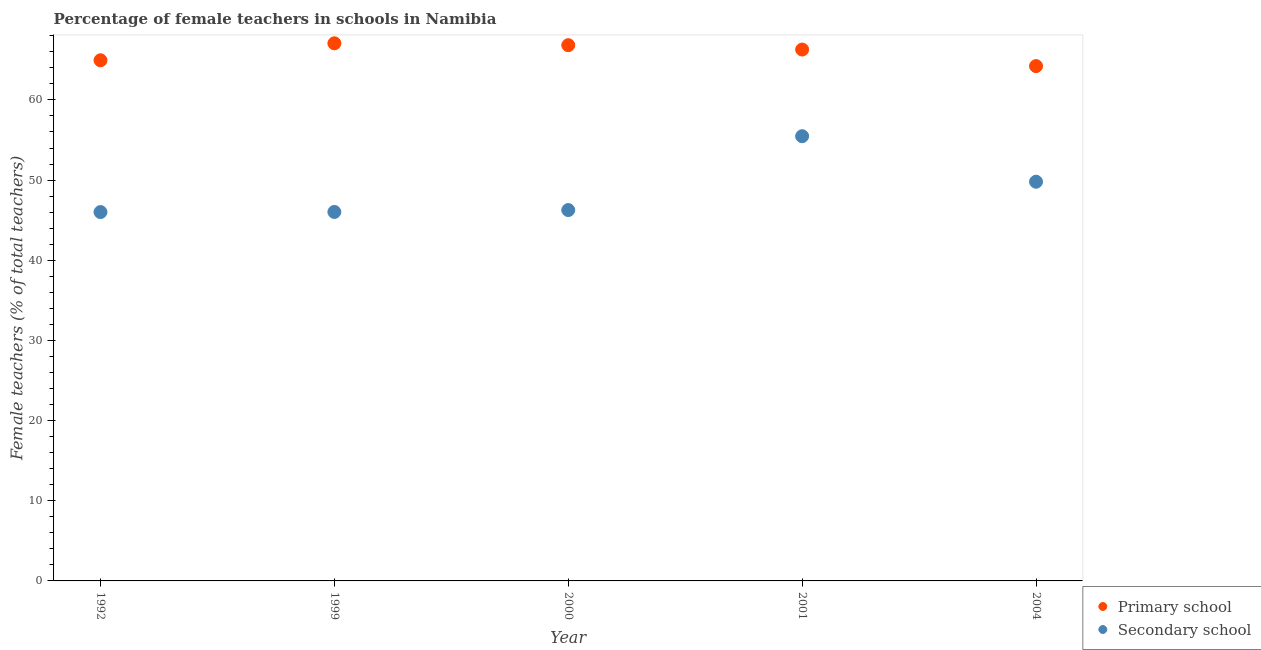How many different coloured dotlines are there?
Provide a short and direct response. 2. Is the number of dotlines equal to the number of legend labels?
Offer a terse response. Yes. What is the percentage of female teachers in primary schools in 2004?
Provide a short and direct response. 64.22. Across all years, what is the maximum percentage of female teachers in secondary schools?
Offer a very short reply. 55.47. Across all years, what is the minimum percentage of female teachers in primary schools?
Keep it short and to the point. 64.22. In which year was the percentage of female teachers in primary schools maximum?
Ensure brevity in your answer.  1999. What is the total percentage of female teachers in primary schools in the graph?
Provide a short and direct response. 329.34. What is the difference between the percentage of female teachers in primary schools in 1992 and that in 2001?
Provide a short and direct response. -1.34. What is the difference between the percentage of female teachers in primary schools in 1999 and the percentage of female teachers in secondary schools in 2000?
Give a very brief answer. 20.8. What is the average percentage of female teachers in secondary schools per year?
Offer a terse response. 48.71. In the year 1992, what is the difference between the percentage of female teachers in secondary schools and percentage of female teachers in primary schools?
Provide a succinct answer. -18.94. In how many years, is the percentage of female teachers in primary schools greater than 54 %?
Make the answer very short. 5. What is the ratio of the percentage of female teachers in secondary schools in 1999 to that in 2001?
Keep it short and to the point. 0.83. Is the percentage of female teachers in primary schools in 1992 less than that in 2004?
Make the answer very short. No. Is the difference between the percentage of female teachers in primary schools in 2000 and 2001 greater than the difference between the percentage of female teachers in secondary schools in 2000 and 2001?
Ensure brevity in your answer.  Yes. What is the difference between the highest and the second highest percentage of female teachers in primary schools?
Your response must be concise. 0.23. What is the difference between the highest and the lowest percentage of female teachers in primary schools?
Provide a short and direct response. 2.84. In how many years, is the percentage of female teachers in primary schools greater than the average percentage of female teachers in primary schools taken over all years?
Make the answer very short. 3. Is the percentage of female teachers in primary schools strictly less than the percentage of female teachers in secondary schools over the years?
Make the answer very short. No. How many years are there in the graph?
Your answer should be very brief. 5. Are the values on the major ticks of Y-axis written in scientific E-notation?
Keep it short and to the point. No. Does the graph contain any zero values?
Offer a very short reply. No. How are the legend labels stacked?
Your response must be concise. Vertical. What is the title of the graph?
Your answer should be very brief. Percentage of female teachers in schools in Namibia. What is the label or title of the X-axis?
Offer a very short reply. Year. What is the label or title of the Y-axis?
Provide a succinct answer. Female teachers (% of total teachers). What is the Female teachers (% of total teachers) in Primary school in 1992?
Offer a terse response. 64.95. What is the Female teachers (% of total teachers) in Secondary school in 1992?
Keep it short and to the point. 46.01. What is the Female teachers (% of total teachers) of Primary school in 1999?
Offer a very short reply. 67.06. What is the Female teachers (% of total teachers) in Secondary school in 1999?
Offer a very short reply. 46.03. What is the Female teachers (% of total teachers) of Primary school in 2000?
Your answer should be compact. 66.83. What is the Female teachers (% of total teachers) of Secondary school in 2000?
Offer a very short reply. 46.26. What is the Female teachers (% of total teachers) of Primary school in 2001?
Offer a terse response. 66.29. What is the Female teachers (% of total teachers) of Secondary school in 2001?
Your answer should be compact. 55.47. What is the Female teachers (% of total teachers) of Primary school in 2004?
Offer a terse response. 64.22. What is the Female teachers (% of total teachers) of Secondary school in 2004?
Give a very brief answer. 49.8. Across all years, what is the maximum Female teachers (% of total teachers) of Primary school?
Ensure brevity in your answer.  67.06. Across all years, what is the maximum Female teachers (% of total teachers) of Secondary school?
Your answer should be very brief. 55.47. Across all years, what is the minimum Female teachers (% of total teachers) of Primary school?
Make the answer very short. 64.22. Across all years, what is the minimum Female teachers (% of total teachers) of Secondary school?
Your answer should be very brief. 46.01. What is the total Female teachers (% of total teachers) in Primary school in the graph?
Make the answer very short. 329.34. What is the total Female teachers (% of total teachers) of Secondary school in the graph?
Ensure brevity in your answer.  243.57. What is the difference between the Female teachers (% of total teachers) of Primary school in 1992 and that in 1999?
Your answer should be very brief. -2.12. What is the difference between the Female teachers (% of total teachers) in Secondary school in 1992 and that in 1999?
Provide a succinct answer. -0.01. What is the difference between the Female teachers (% of total teachers) of Primary school in 1992 and that in 2000?
Offer a very short reply. -1.88. What is the difference between the Female teachers (% of total teachers) of Secondary school in 1992 and that in 2000?
Offer a terse response. -0.25. What is the difference between the Female teachers (% of total teachers) in Primary school in 1992 and that in 2001?
Provide a succinct answer. -1.34. What is the difference between the Female teachers (% of total teachers) in Secondary school in 1992 and that in 2001?
Your answer should be compact. -9.46. What is the difference between the Female teachers (% of total teachers) of Primary school in 1992 and that in 2004?
Give a very brief answer. 0.73. What is the difference between the Female teachers (% of total teachers) of Secondary school in 1992 and that in 2004?
Provide a short and direct response. -3.79. What is the difference between the Female teachers (% of total teachers) of Primary school in 1999 and that in 2000?
Ensure brevity in your answer.  0.23. What is the difference between the Female teachers (% of total teachers) of Secondary school in 1999 and that in 2000?
Ensure brevity in your answer.  -0.24. What is the difference between the Female teachers (% of total teachers) in Primary school in 1999 and that in 2001?
Provide a short and direct response. 0.78. What is the difference between the Female teachers (% of total teachers) of Secondary school in 1999 and that in 2001?
Your answer should be very brief. -9.45. What is the difference between the Female teachers (% of total teachers) of Primary school in 1999 and that in 2004?
Provide a short and direct response. 2.84. What is the difference between the Female teachers (% of total teachers) in Secondary school in 1999 and that in 2004?
Offer a very short reply. -3.77. What is the difference between the Female teachers (% of total teachers) in Primary school in 2000 and that in 2001?
Give a very brief answer. 0.54. What is the difference between the Female teachers (% of total teachers) of Secondary school in 2000 and that in 2001?
Offer a very short reply. -9.21. What is the difference between the Female teachers (% of total teachers) in Primary school in 2000 and that in 2004?
Your answer should be compact. 2.61. What is the difference between the Female teachers (% of total teachers) in Secondary school in 2000 and that in 2004?
Ensure brevity in your answer.  -3.53. What is the difference between the Female teachers (% of total teachers) in Primary school in 2001 and that in 2004?
Offer a terse response. 2.07. What is the difference between the Female teachers (% of total teachers) of Secondary school in 2001 and that in 2004?
Keep it short and to the point. 5.68. What is the difference between the Female teachers (% of total teachers) in Primary school in 1992 and the Female teachers (% of total teachers) in Secondary school in 1999?
Offer a terse response. 18.92. What is the difference between the Female teachers (% of total teachers) of Primary school in 1992 and the Female teachers (% of total teachers) of Secondary school in 2000?
Provide a short and direct response. 18.68. What is the difference between the Female teachers (% of total teachers) of Primary school in 1992 and the Female teachers (% of total teachers) of Secondary school in 2001?
Your response must be concise. 9.47. What is the difference between the Female teachers (% of total teachers) of Primary school in 1992 and the Female teachers (% of total teachers) of Secondary school in 2004?
Give a very brief answer. 15.15. What is the difference between the Female teachers (% of total teachers) of Primary school in 1999 and the Female teachers (% of total teachers) of Secondary school in 2000?
Your answer should be very brief. 20.8. What is the difference between the Female teachers (% of total teachers) in Primary school in 1999 and the Female teachers (% of total teachers) in Secondary school in 2001?
Provide a short and direct response. 11.59. What is the difference between the Female teachers (% of total teachers) in Primary school in 1999 and the Female teachers (% of total teachers) in Secondary school in 2004?
Offer a terse response. 17.27. What is the difference between the Female teachers (% of total teachers) in Primary school in 2000 and the Female teachers (% of total teachers) in Secondary school in 2001?
Your answer should be very brief. 11.35. What is the difference between the Female teachers (% of total teachers) in Primary school in 2000 and the Female teachers (% of total teachers) in Secondary school in 2004?
Give a very brief answer. 17.03. What is the difference between the Female teachers (% of total teachers) of Primary school in 2001 and the Female teachers (% of total teachers) of Secondary school in 2004?
Offer a very short reply. 16.49. What is the average Female teachers (% of total teachers) of Primary school per year?
Your answer should be very brief. 65.87. What is the average Female teachers (% of total teachers) of Secondary school per year?
Make the answer very short. 48.71. In the year 1992, what is the difference between the Female teachers (% of total teachers) of Primary school and Female teachers (% of total teachers) of Secondary school?
Keep it short and to the point. 18.94. In the year 1999, what is the difference between the Female teachers (% of total teachers) in Primary school and Female teachers (% of total teachers) in Secondary school?
Offer a terse response. 21.04. In the year 2000, what is the difference between the Female teachers (% of total teachers) of Primary school and Female teachers (% of total teachers) of Secondary school?
Your answer should be compact. 20.57. In the year 2001, what is the difference between the Female teachers (% of total teachers) of Primary school and Female teachers (% of total teachers) of Secondary school?
Give a very brief answer. 10.81. In the year 2004, what is the difference between the Female teachers (% of total teachers) in Primary school and Female teachers (% of total teachers) in Secondary school?
Provide a succinct answer. 14.42. What is the ratio of the Female teachers (% of total teachers) in Primary school in 1992 to that in 1999?
Ensure brevity in your answer.  0.97. What is the ratio of the Female teachers (% of total teachers) of Secondary school in 1992 to that in 1999?
Give a very brief answer. 1. What is the ratio of the Female teachers (% of total teachers) of Primary school in 1992 to that in 2000?
Your answer should be compact. 0.97. What is the ratio of the Female teachers (% of total teachers) in Primary school in 1992 to that in 2001?
Your answer should be compact. 0.98. What is the ratio of the Female teachers (% of total teachers) of Secondary school in 1992 to that in 2001?
Keep it short and to the point. 0.83. What is the ratio of the Female teachers (% of total teachers) in Primary school in 1992 to that in 2004?
Ensure brevity in your answer.  1.01. What is the ratio of the Female teachers (% of total teachers) in Secondary school in 1992 to that in 2004?
Your answer should be compact. 0.92. What is the ratio of the Female teachers (% of total teachers) of Primary school in 1999 to that in 2001?
Offer a terse response. 1.01. What is the ratio of the Female teachers (% of total teachers) of Secondary school in 1999 to that in 2001?
Offer a terse response. 0.83. What is the ratio of the Female teachers (% of total teachers) in Primary school in 1999 to that in 2004?
Provide a short and direct response. 1.04. What is the ratio of the Female teachers (% of total teachers) of Secondary school in 1999 to that in 2004?
Keep it short and to the point. 0.92. What is the ratio of the Female teachers (% of total teachers) of Primary school in 2000 to that in 2001?
Your response must be concise. 1.01. What is the ratio of the Female teachers (% of total teachers) of Secondary school in 2000 to that in 2001?
Provide a succinct answer. 0.83. What is the ratio of the Female teachers (% of total teachers) of Primary school in 2000 to that in 2004?
Offer a very short reply. 1.04. What is the ratio of the Female teachers (% of total teachers) of Secondary school in 2000 to that in 2004?
Make the answer very short. 0.93. What is the ratio of the Female teachers (% of total teachers) of Primary school in 2001 to that in 2004?
Make the answer very short. 1.03. What is the ratio of the Female teachers (% of total teachers) in Secondary school in 2001 to that in 2004?
Your response must be concise. 1.11. What is the difference between the highest and the second highest Female teachers (% of total teachers) of Primary school?
Your answer should be very brief. 0.23. What is the difference between the highest and the second highest Female teachers (% of total teachers) in Secondary school?
Your answer should be compact. 5.68. What is the difference between the highest and the lowest Female teachers (% of total teachers) in Primary school?
Offer a terse response. 2.84. What is the difference between the highest and the lowest Female teachers (% of total teachers) in Secondary school?
Your answer should be very brief. 9.46. 